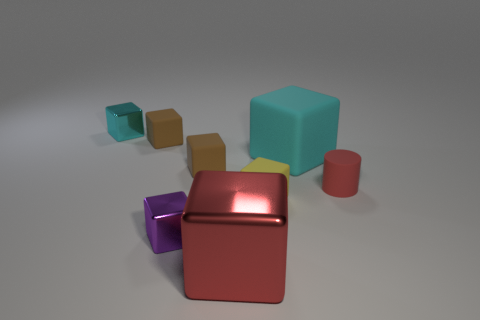Are there fewer yellow rubber things that are behind the cyan matte object than large matte blocks that are on the left side of the red shiny cube?
Your response must be concise. No. How many red objects are either big metal cylinders or big things?
Provide a succinct answer. 1. Are there an equal number of yellow cubes that are behind the small rubber cylinder and small brown rubber blocks?
Keep it short and to the point. No. What number of objects are purple rubber balls or tiny cubes in front of the cyan metallic thing?
Provide a short and direct response. 4. Does the large metal object have the same color as the rubber cylinder?
Ensure brevity in your answer.  Yes. Is there a red cylinder that has the same material as the small purple thing?
Keep it short and to the point. No. What color is the other big metal thing that is the same shape as the purple object?
Provide a short and direct response. Red. Is the small yellow thing made of the same material as the cyan object that is to the left of the large red metallic block?
Offer a very short reply. No. The tiny brown object that is in front of the large thing that is behind the red shiny object is what shape?
Ensure brevity in your answer.  Cube. There is a cyan cube that is to the left of the red metal object; is its size the same as the large matte block?
Make the answer very short. No. 